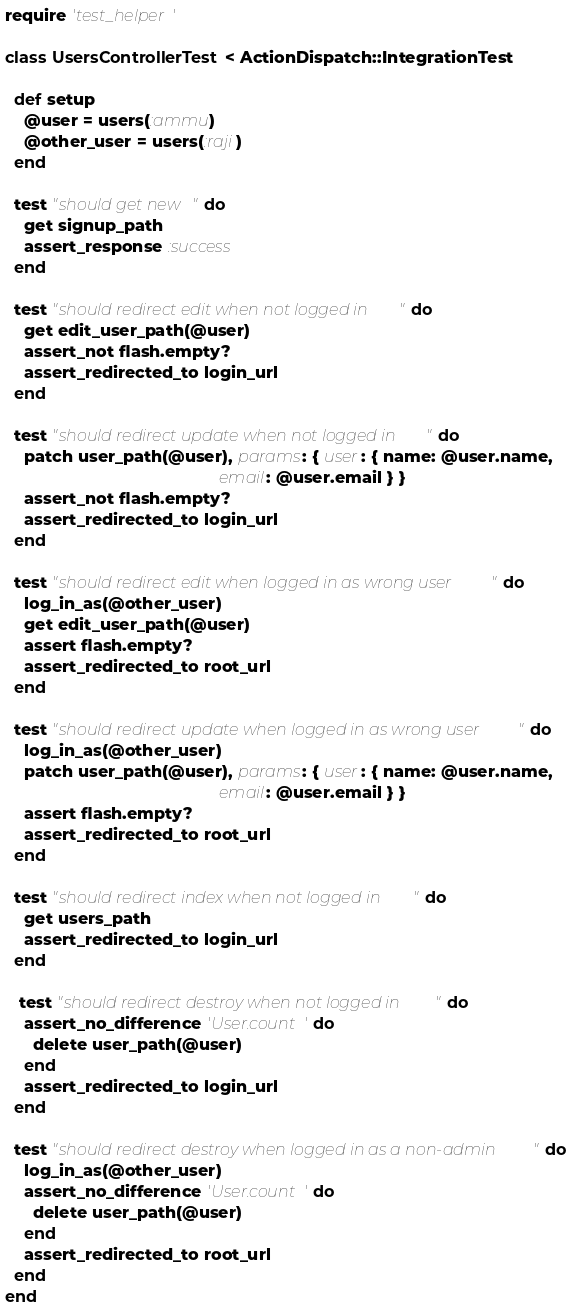<code> <loc_0><loc_0><loc_500><loc_500><_Ruby_>require 'test_helper'

class UsersControllerTest < ActionDispatch::IntegrationTest
  
  def setup
    @user = users(:ammu)
    @other_user = users(:raji)
  end

  test "should get new" do
    get signup_path
    assert_response :success
  end

  test "should redirect edit when not logged in" do
    get edit_user_path(@user)
    assert_not flash.empty?
    assert_redirected_to login_url
  end

  test "should redirect update when not logged in" do
    patch user_path(@user), params: { user: { name: @user.name,
                                              email: @user.email } }
    assert_not flash.empty?
    assert_redirected_to login_url
  end

  test "should redirect edit when logged in as wrong user" do
    log_in_as(@other_user)
    get edit_user_path(@user)
    assert flash.empty?
    assert_redirected_to root_url
  end

  test "should redirect update when logged in as wrong user" do
    log_in_as(@other_user)
    patch user_path(@user), params: { user: { name: @user.name,
                                              email: @user.email } }
    assert flash.empty?
    assert_redirected_to root_url
  end

  test "should redirect index when not logged in" do
    get users_path
    assert_redirected_to login_url
  end

   test "should redirect destroy when not logged in" do
    assert_no_difference 'User.count' do
      delete user_path(@user)
    end
    assert_redirected_to login_url
  end

  test "should redirect destroy when logged in as a non-admin" do
    log_in_as(@other_user)
    assert_no_difference 'User.count' do
      delete user_path(@user)
    end
    assert_redirected_to root_url
  end
end
</code> 